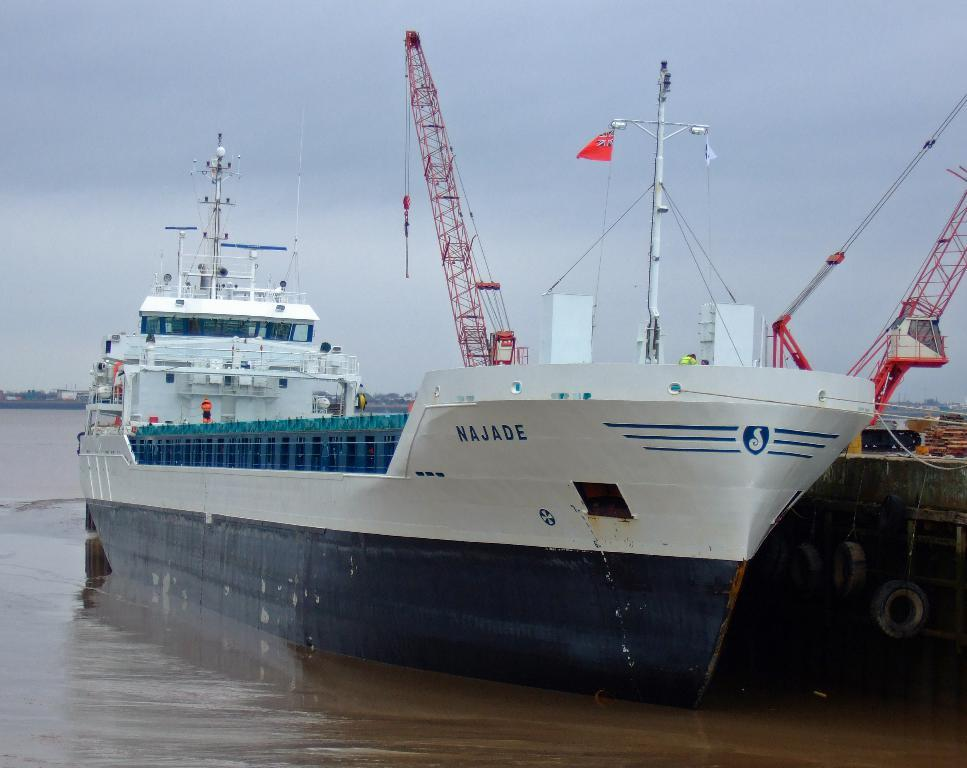What type of vehicles can be seen in the image? There are ships in the image. Where are the ships located? The ships are on the water. What other objects can be seen in the image? There are cranes in the image. What is visible in the background of the image? The sky is visible in the background of the image. What symbol or emblem is present in the image? There is a flag in the image. What type of iron can be seen covering the ships in the image? There is no iron covering the ships in the image; they are on the water. How many pins are used to hold the flag in the image? There is no information about pins in the image; only the flag is mentioned. 